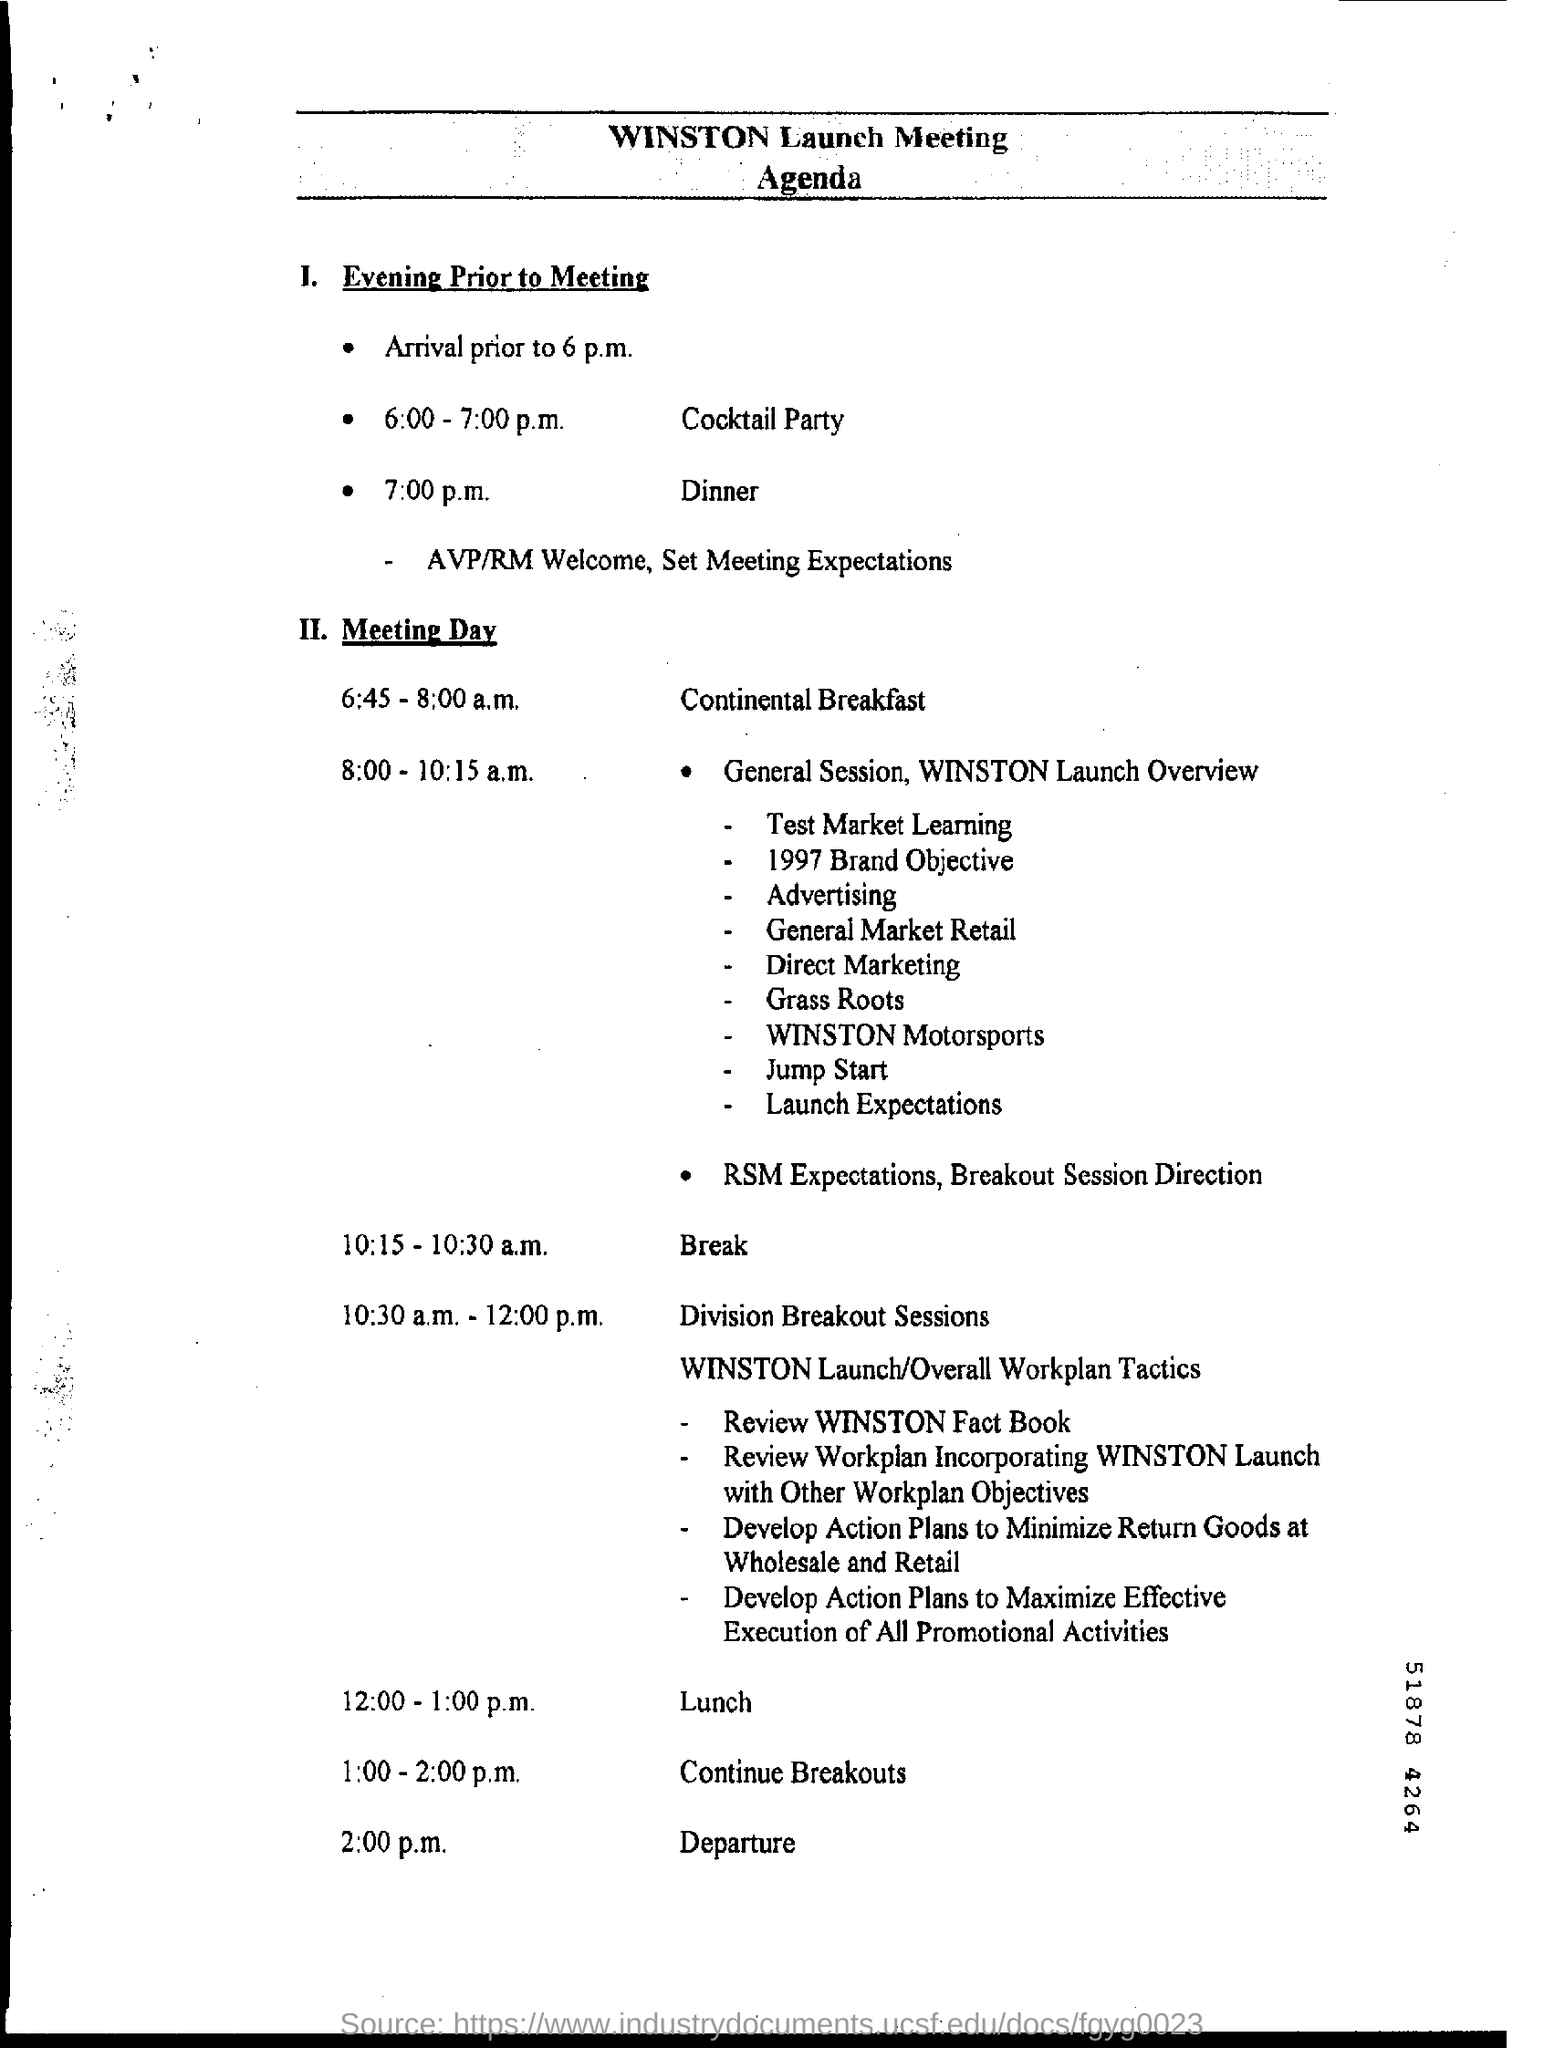Outline some significant characteristics in this image. The cocktail party will take place from 6:00 to 7:00 p.m. The time for lunch is from 12:00 to 1:00 p.m. It is 7:00 p.m. and time for dinner. The continental breakfast will take place from 6:45-8:00 a.m. 